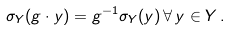<formula> <loc_0><loc_0><loc_500><loc_500>\sigma _ { Y } ( g \cdot y ) = g ^ { - 1 } \sigma _ { Y } ( y ) \, \forall \, y \in Y \, .</formula> 